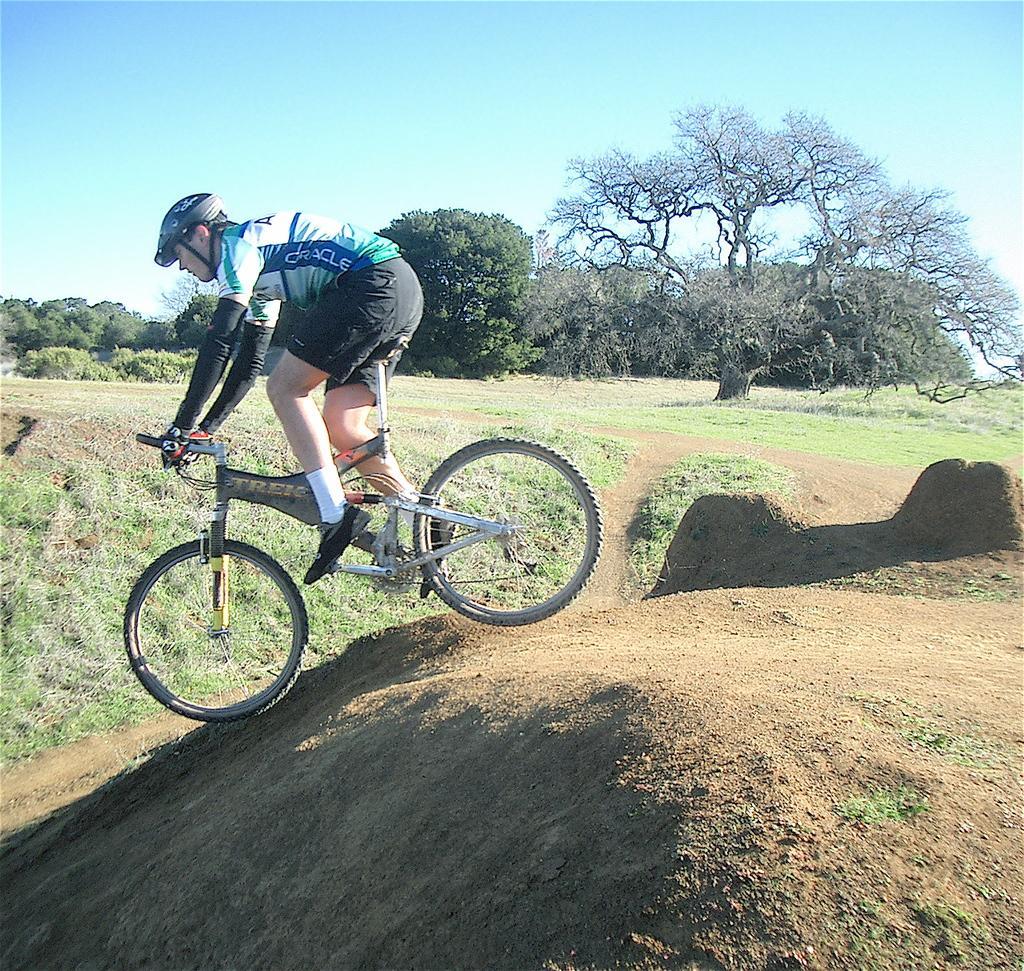Describe this image in one or two sentences. In this image there is a man riding a bicycle in the center. In the background there is grass on the ground and there are trees. 